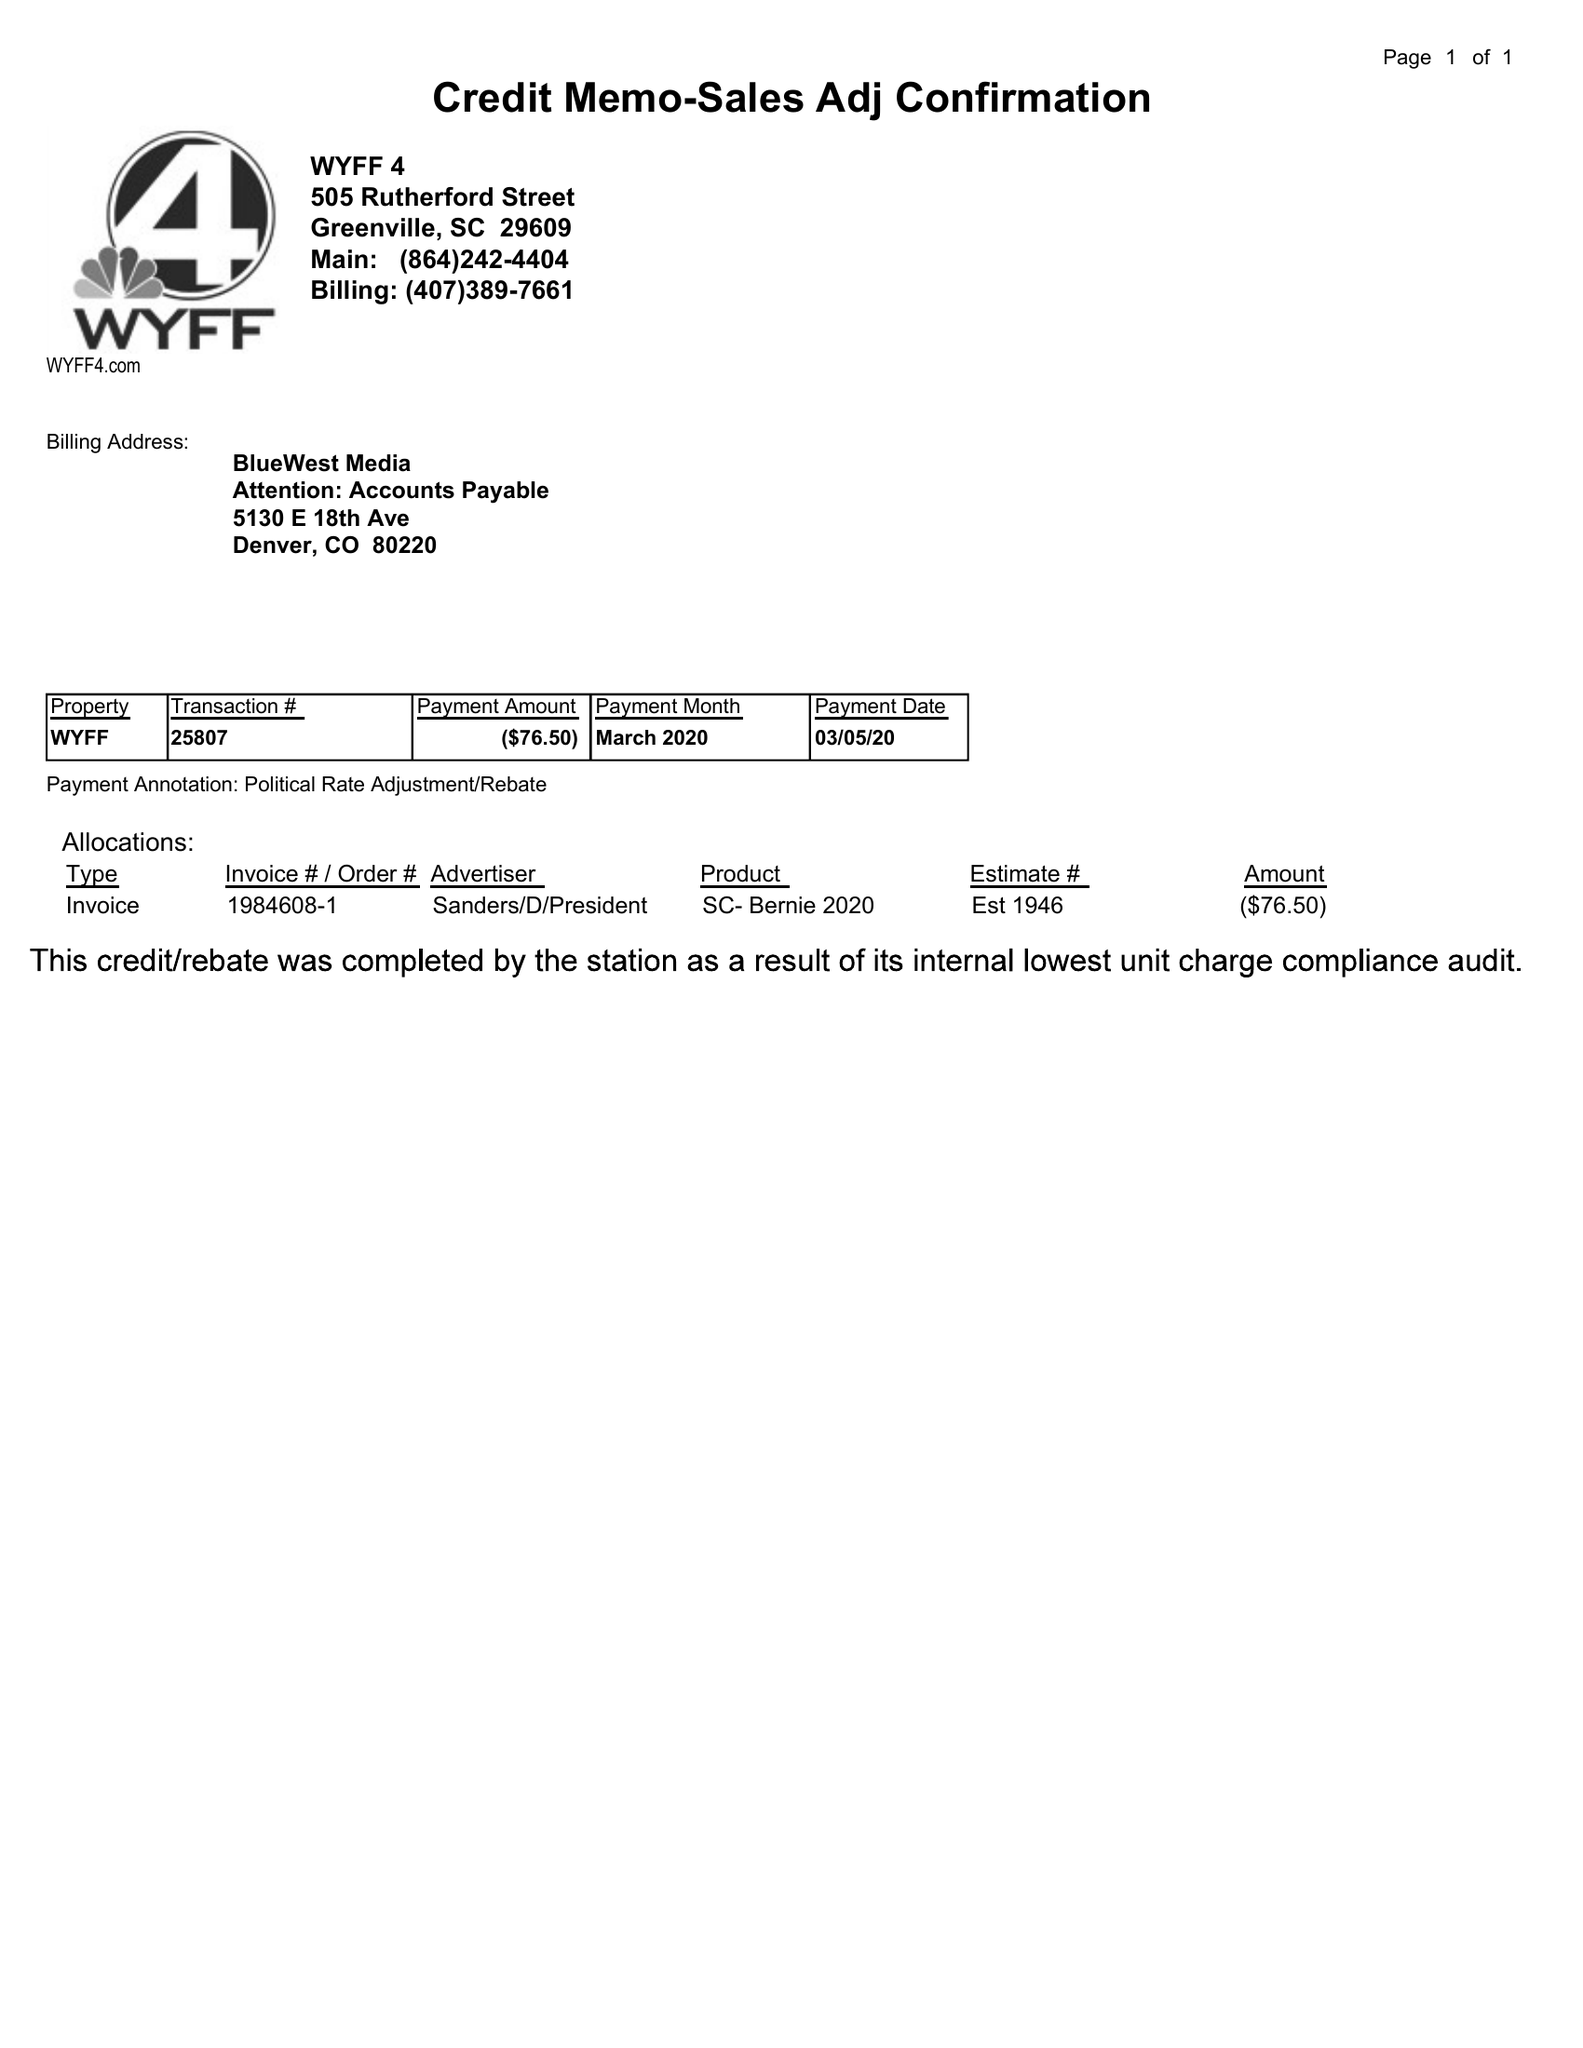What is the value for the flight_to?
Answer the question using a single word or phrase. None 